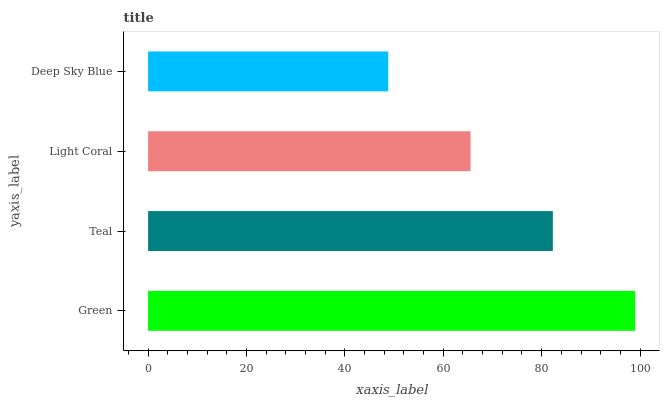Is Deep Sky Blue the minimum?
Answer yes or no. Yes. Is Green the maximum?
Answer yes or no. Yes. Is Teal the minimum?
Answer yes or no. No. Is Teal the maximum?
Answer yes or no. No. Is Green greater than Teal?
Answer yes or no. Yes. Is Teal less than Green?
Answer yes or no. Yes. Is Teal greater than Green?
Answer yes or no. No. Is Green less than Teal?
Answer yes or no. No. Is Teal the high median?
Answer yes or no. Yes. Is Light Coral the low median?
Answer yes or no. Yes. Is Deep Sky Blue the high median?
Answer yes or no. No. Is Deep Sky Blue the low median?
Answer yes or no. No. 